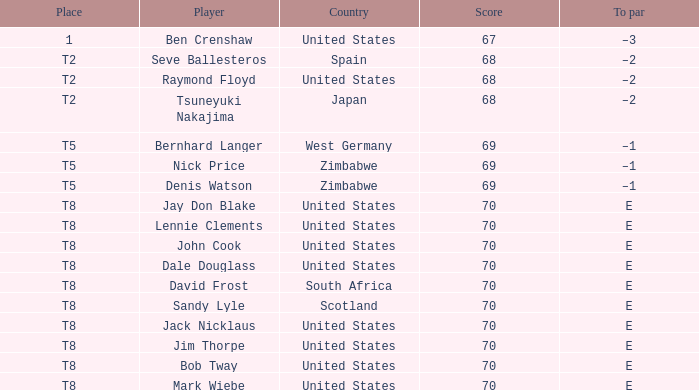What player has E as the to par, and The United States as the country? Jay Don Blake, Lennie Clements, John Cook, Dale Douglass, Jack Nicklaus, Jim Thorpe, Bob Tway, Mark Wiebe. 